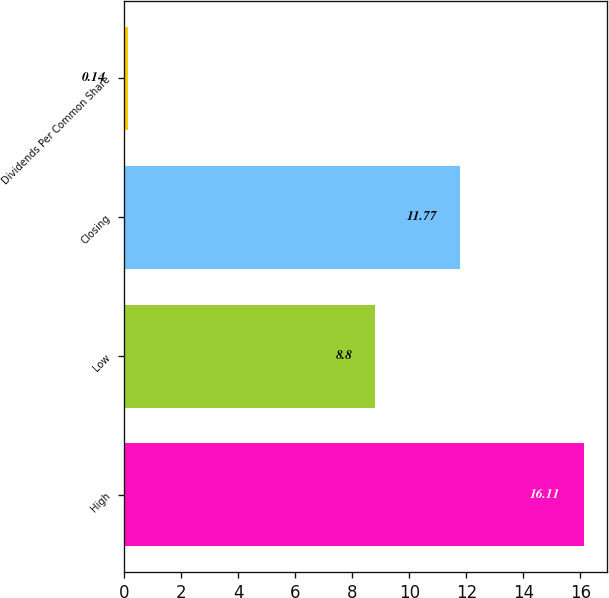Convert chart to OTSL. <chart><loc_0><loc_0><loc_500><loc_500><bar_chart><fcel>High<fcel>Low<fcel>Closing<fcel>Dividends Per Common Share<nl><fcel>16.11<fcel>8.8<fcel>11.77<fcel>0.14<nl></chart> 